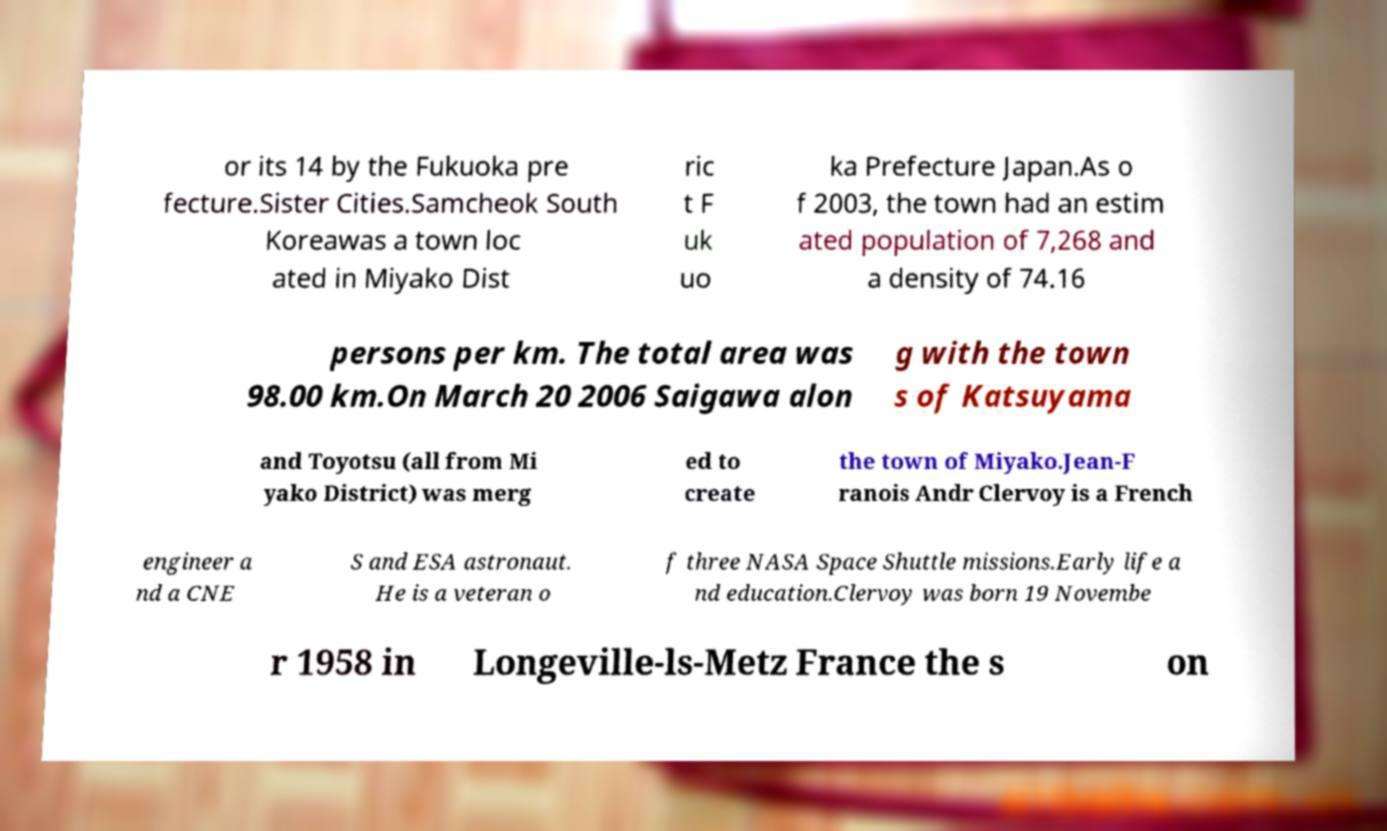Could you extract and type out the text from this image? or its 14 by the Fukuoka pre fecture.Sister Cities.Samcheok South Koreawas a town loc ated in Miyako Dist ric t F uk uo ka Prefecture Japan.As o f 2003, the town had an estim ated population of 7,268 and a density of 74.16 persons per km. The total area was 98.00 km.On March 20 2006 Saigawa alon g with the town s of Katsuyama and Toyotsu (all from Mi yako District) was merg ed to create the town of Miyako.Jean-F ranois Andr Clervoy is a French engineer a nd a CNE S and ESA astronaut. He is a veteran o f three NASA Space Shuttle missions.Early life a nd education.Clervoy was born 19 Novembe r 1958 in Longeville-ls-Metz France the s on 